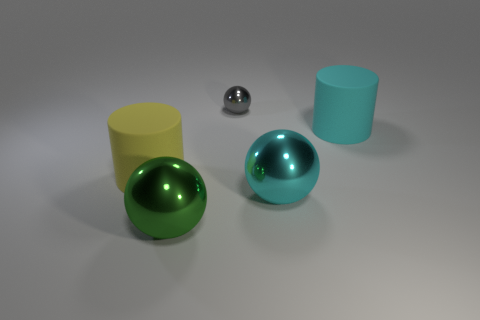Subtract all big balls. How many balls are left? 1 Subtract all spheres. How many objects are left? 2 Add 5 tiny blue balls. How many objects exist? 10 Subtract 1 green balls. How many objects are left? 4 Subtract 1 cylinders. How many cylinders are left? 1 Subtract all yellow cylinders. Subtract all brown cubes. How many cylinders are left? 1 Subtract all blue spheres. How many yellow cylinders are left? 1 Subtract all large green metal cylinders. Subtract all large cyan rubber cylinders. How many objects are left? 4 Add 4 large objects. How many large objects are left? 8 Add 1 tiny gray things. How many tiny gray things exist? 2 